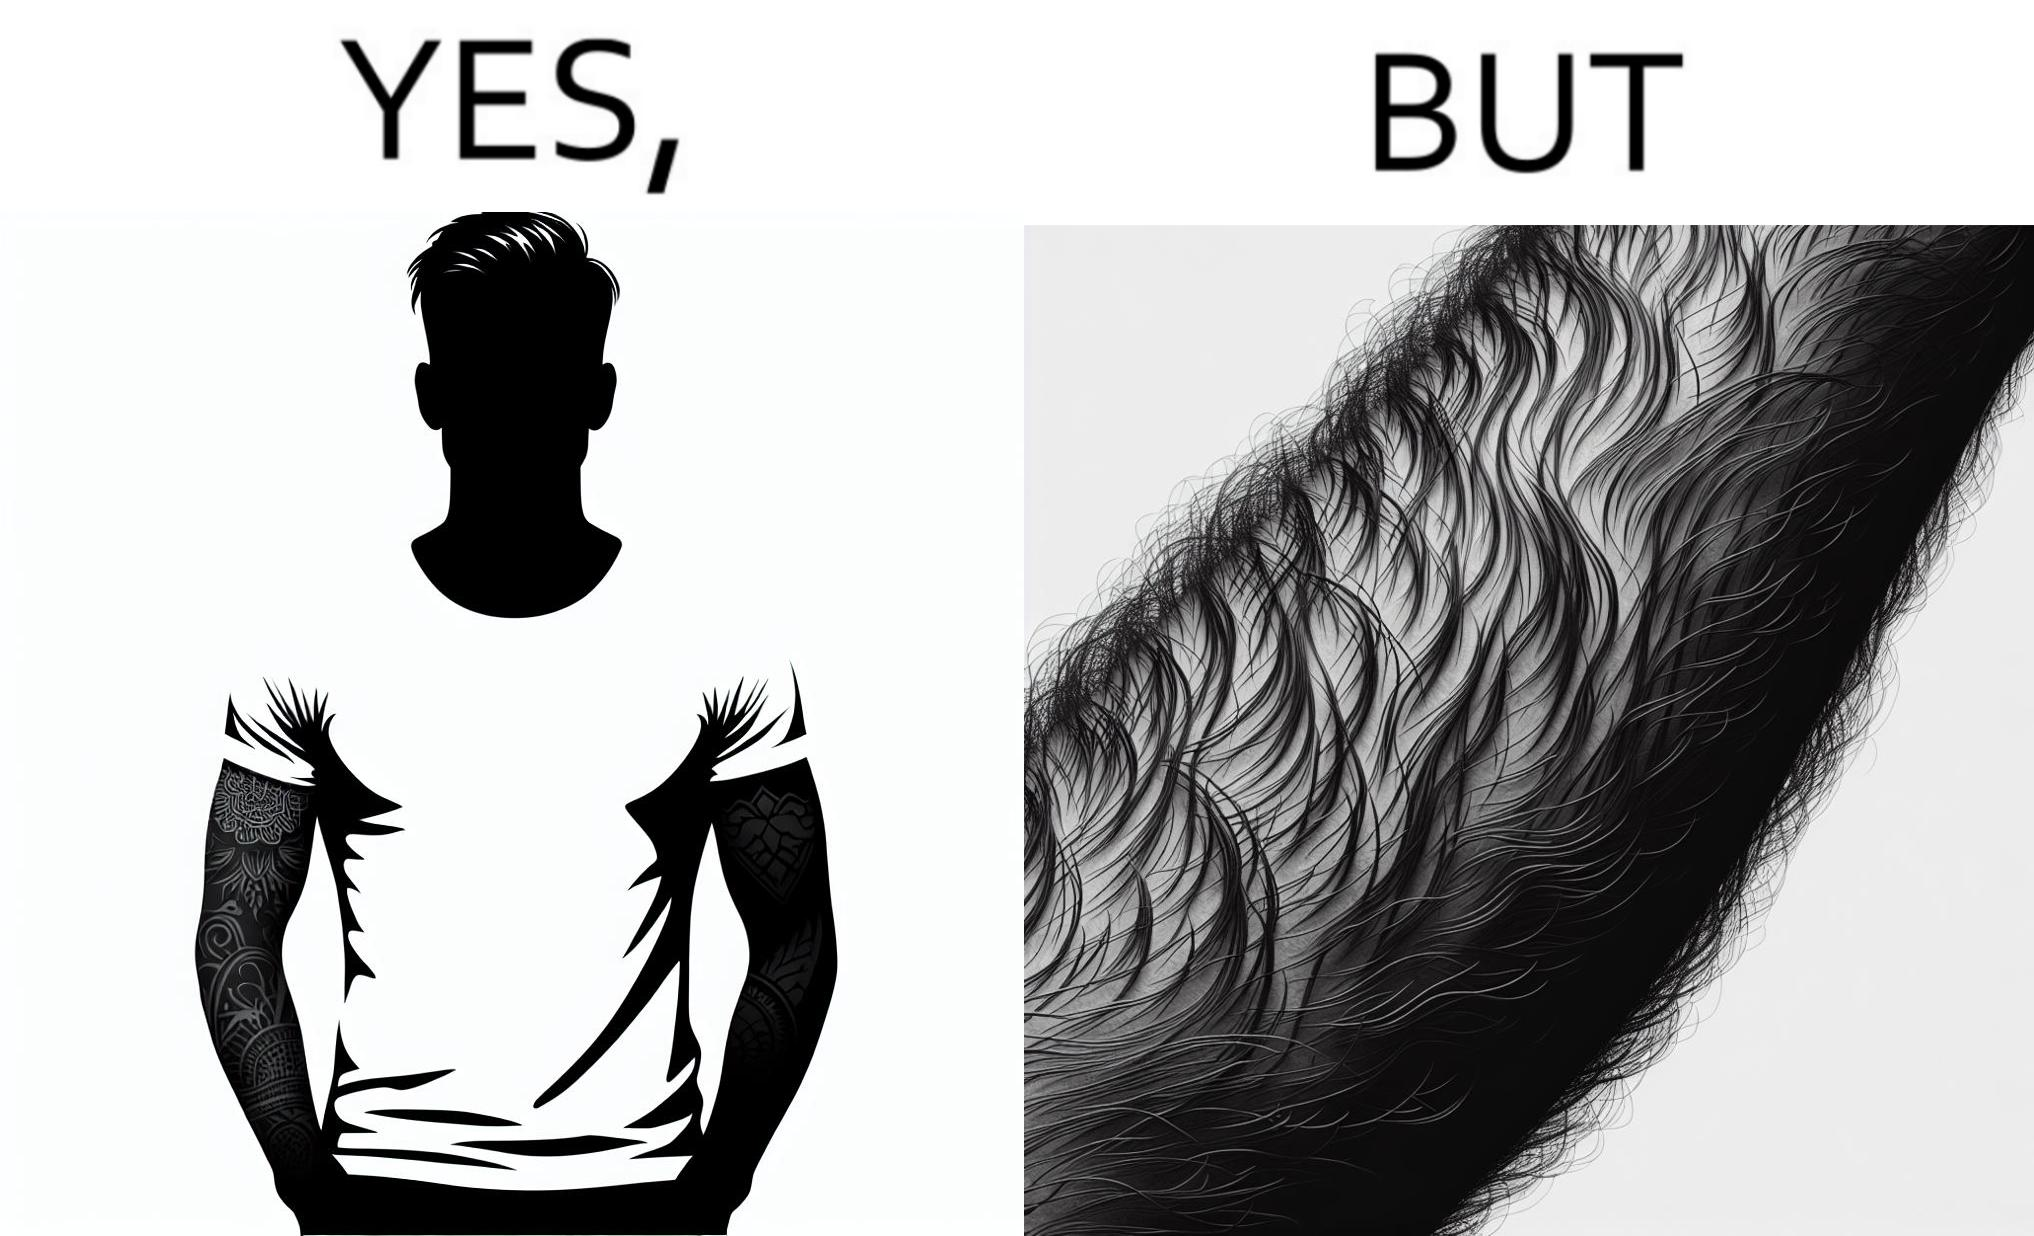What is shown in this image? The image is funny because while from the distance it seems that the man has big tattoos on both of his arms upon a closer look at the arms it turns out there is no tattoo and what seemed to be tattoos are just hairs on his arm. 